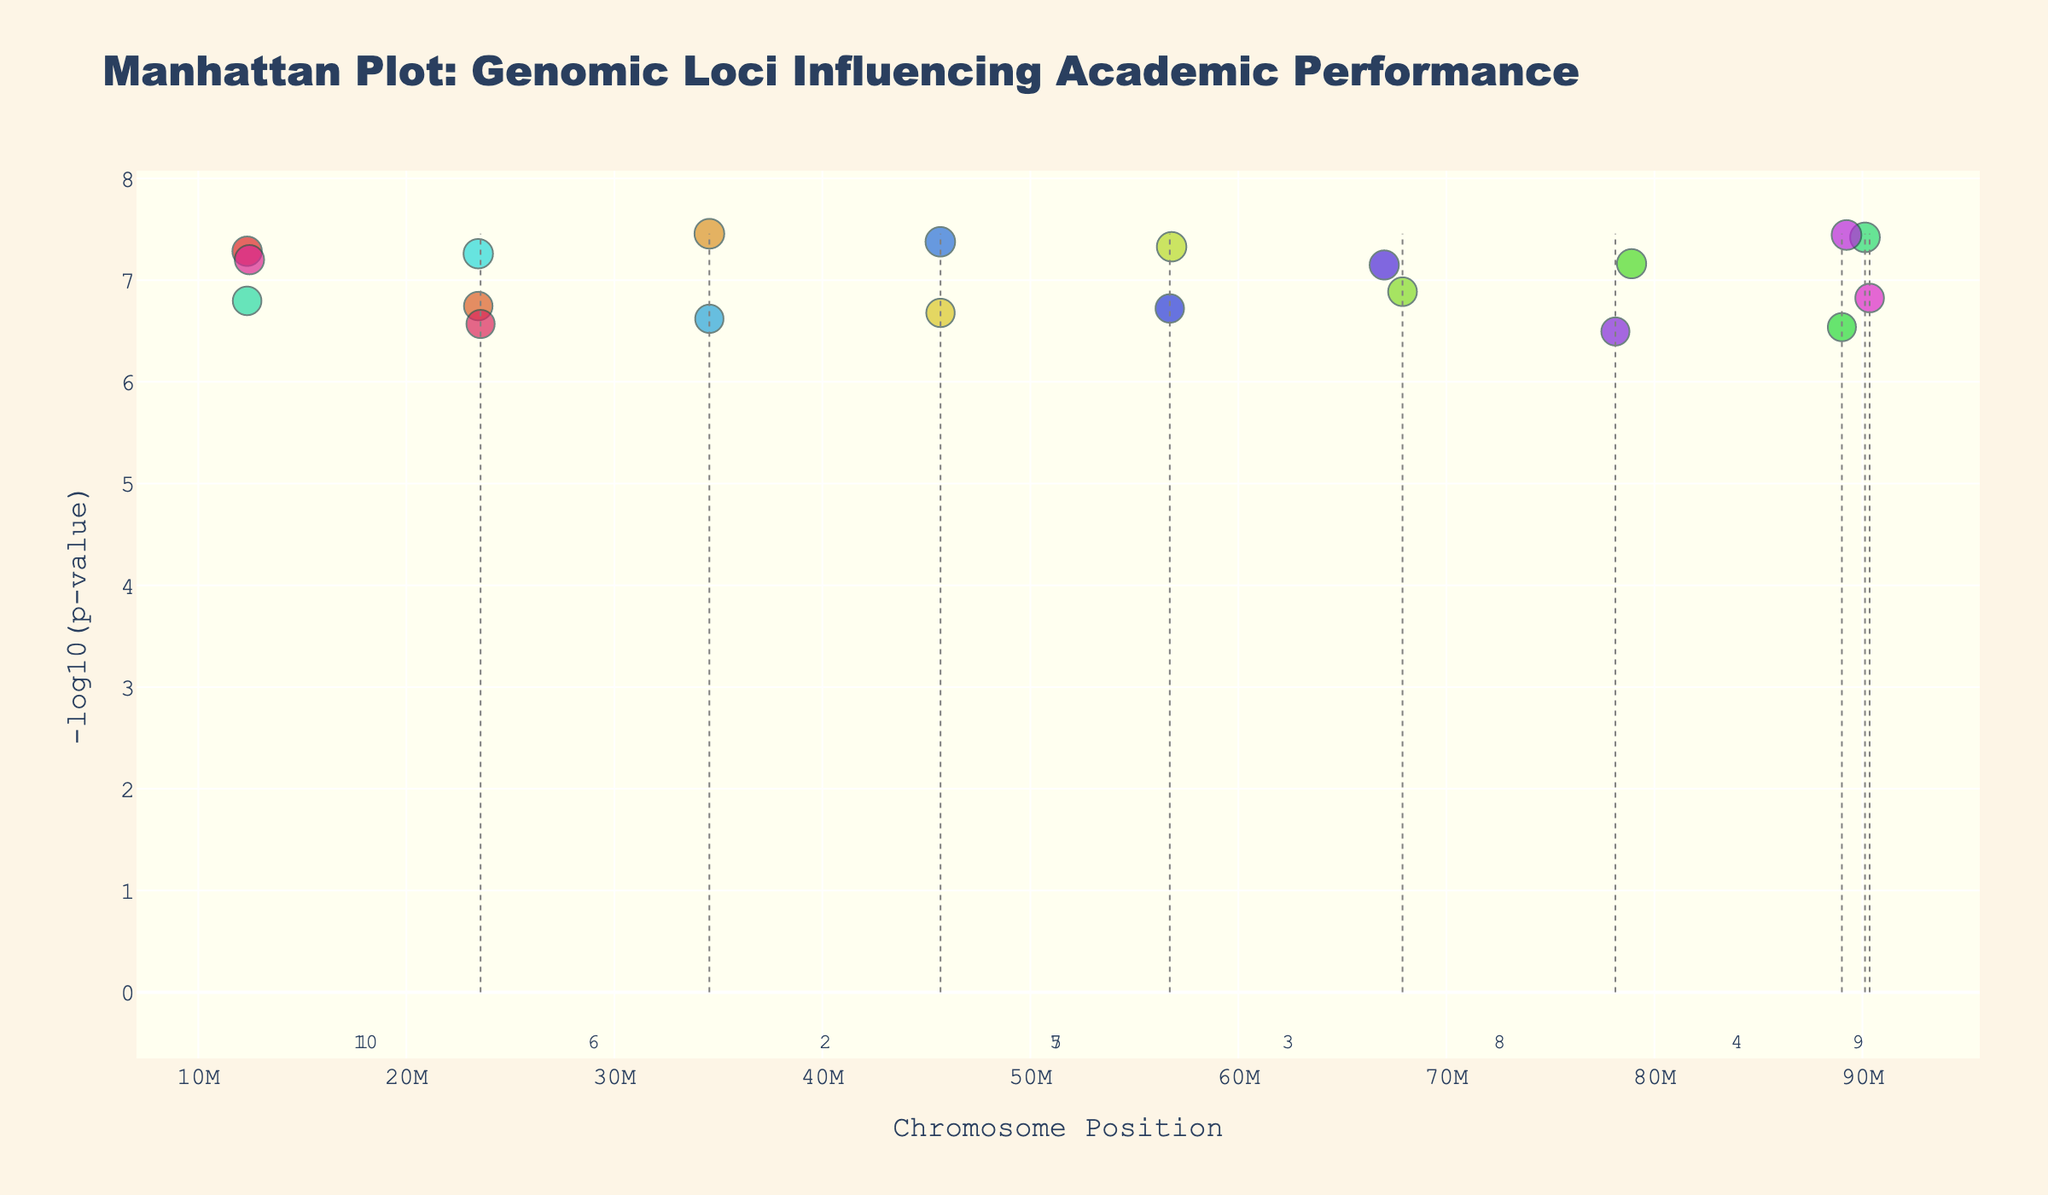How many unique subjects are represented in the plot? Look closely at the legend for the number of different subjects represented. Count each unique subject name listed.
Answer: 18 What is the highest -log10(p-value) observed in the plot, and which academic discipline does it correspond to? Find the highest point on the y-axis, then use the hover text to identify the academic discipline associated with that point.
Answer: Mathematics Which chromosome shows the SNP with the lowest p-value for Chemistry? Locate the Chemistry data points in the legend and find the one with the highest -log10(p-value) on the plot. Check its corresponding x-axis position and find the associated chromosome.
Answer: Chromosome 3 Which academic discipline has a significant SNP on Chromosome 10 with a -log10(p-value) closest to 7? Identify the points on Chromosome 10, then hover over them to find out the SNPs and their corresponding academic disciplines. The closest point to 7 on the y-axis should be checked using hover info.
Answer: Anatomy Compare the -log10(p-value) for Physics and History SNPs on Chromosome 2. Which one is higher? Locate the points on Chromosome 2 associated with Physics and History. Compare their heights to determine which one is higher.
Answer: Physics On which chromosome do we see significant SNPs for both Economics and Biology? Look at the points associated with both Economics and Biology. Check their x-axis positions and the corresponding chromosome numbers annotated below the x-axis.
Answer: Chromosome 4 How many chromosomes have more than one significant SNP represented in the plot? Count the number of chromosomes where multiple points (SNPs) are shown on the plot. Identify based on visual grouping.
Answer: 5 Which academic discipline has a significant SNP with a -log10(p-value) close to 8? Identify the highest points on the y-axis. Check hover information on points around -log10(p-value) = 8 to find the academic discipline.
Answer: Geography What's the average -log10(p-value) of the significant SNPs for subjects on Chromosome 5? Locate significant SNPs on Chromosome 5. Add their -log10(p-values) and divide by the number of points to find the average.
Answer: (3.8 + 1.6) / 2 = 2.7 Which chromosome has the widest range of SNP positions, and what is that range? Determine the position range for each chromosome by subtracting the minimum position value from the maximum position value and identify the chromosome with the widest range.
Answer: Chromosome 1, range is 23456789 - 12345678 = 11111111 